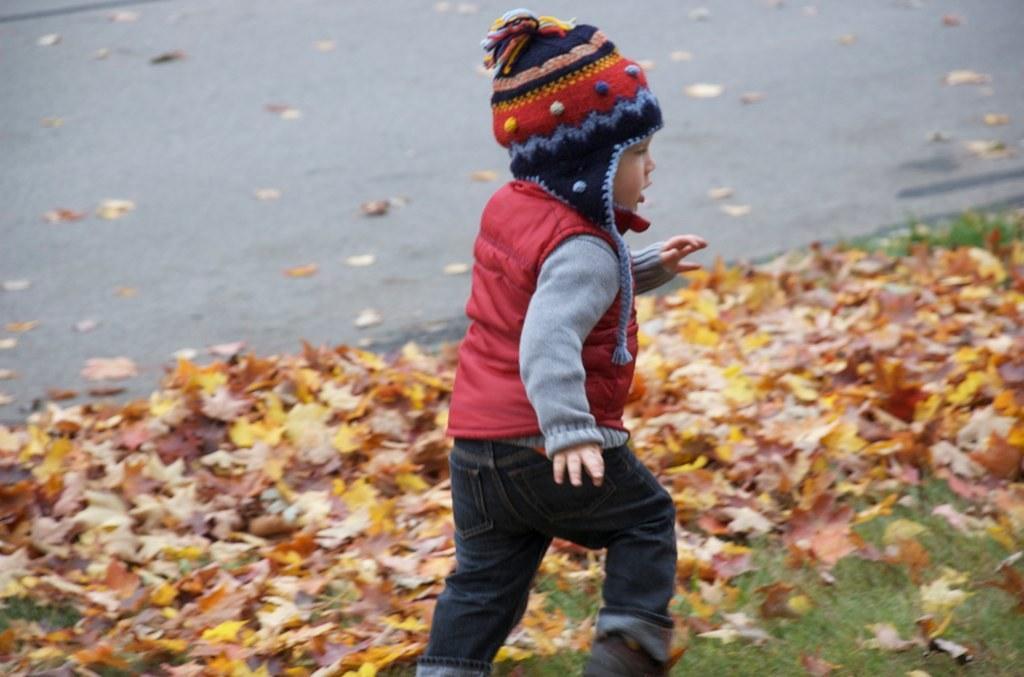Could you give a brief overview of what you see in this image? In this image I can see grass ground and on it I can see a boy is walking. I can also see he is wearing a cap, a red color jacket, grey dress and jeans. I can also see number of leaves on the ground and in the background I can see a road. 